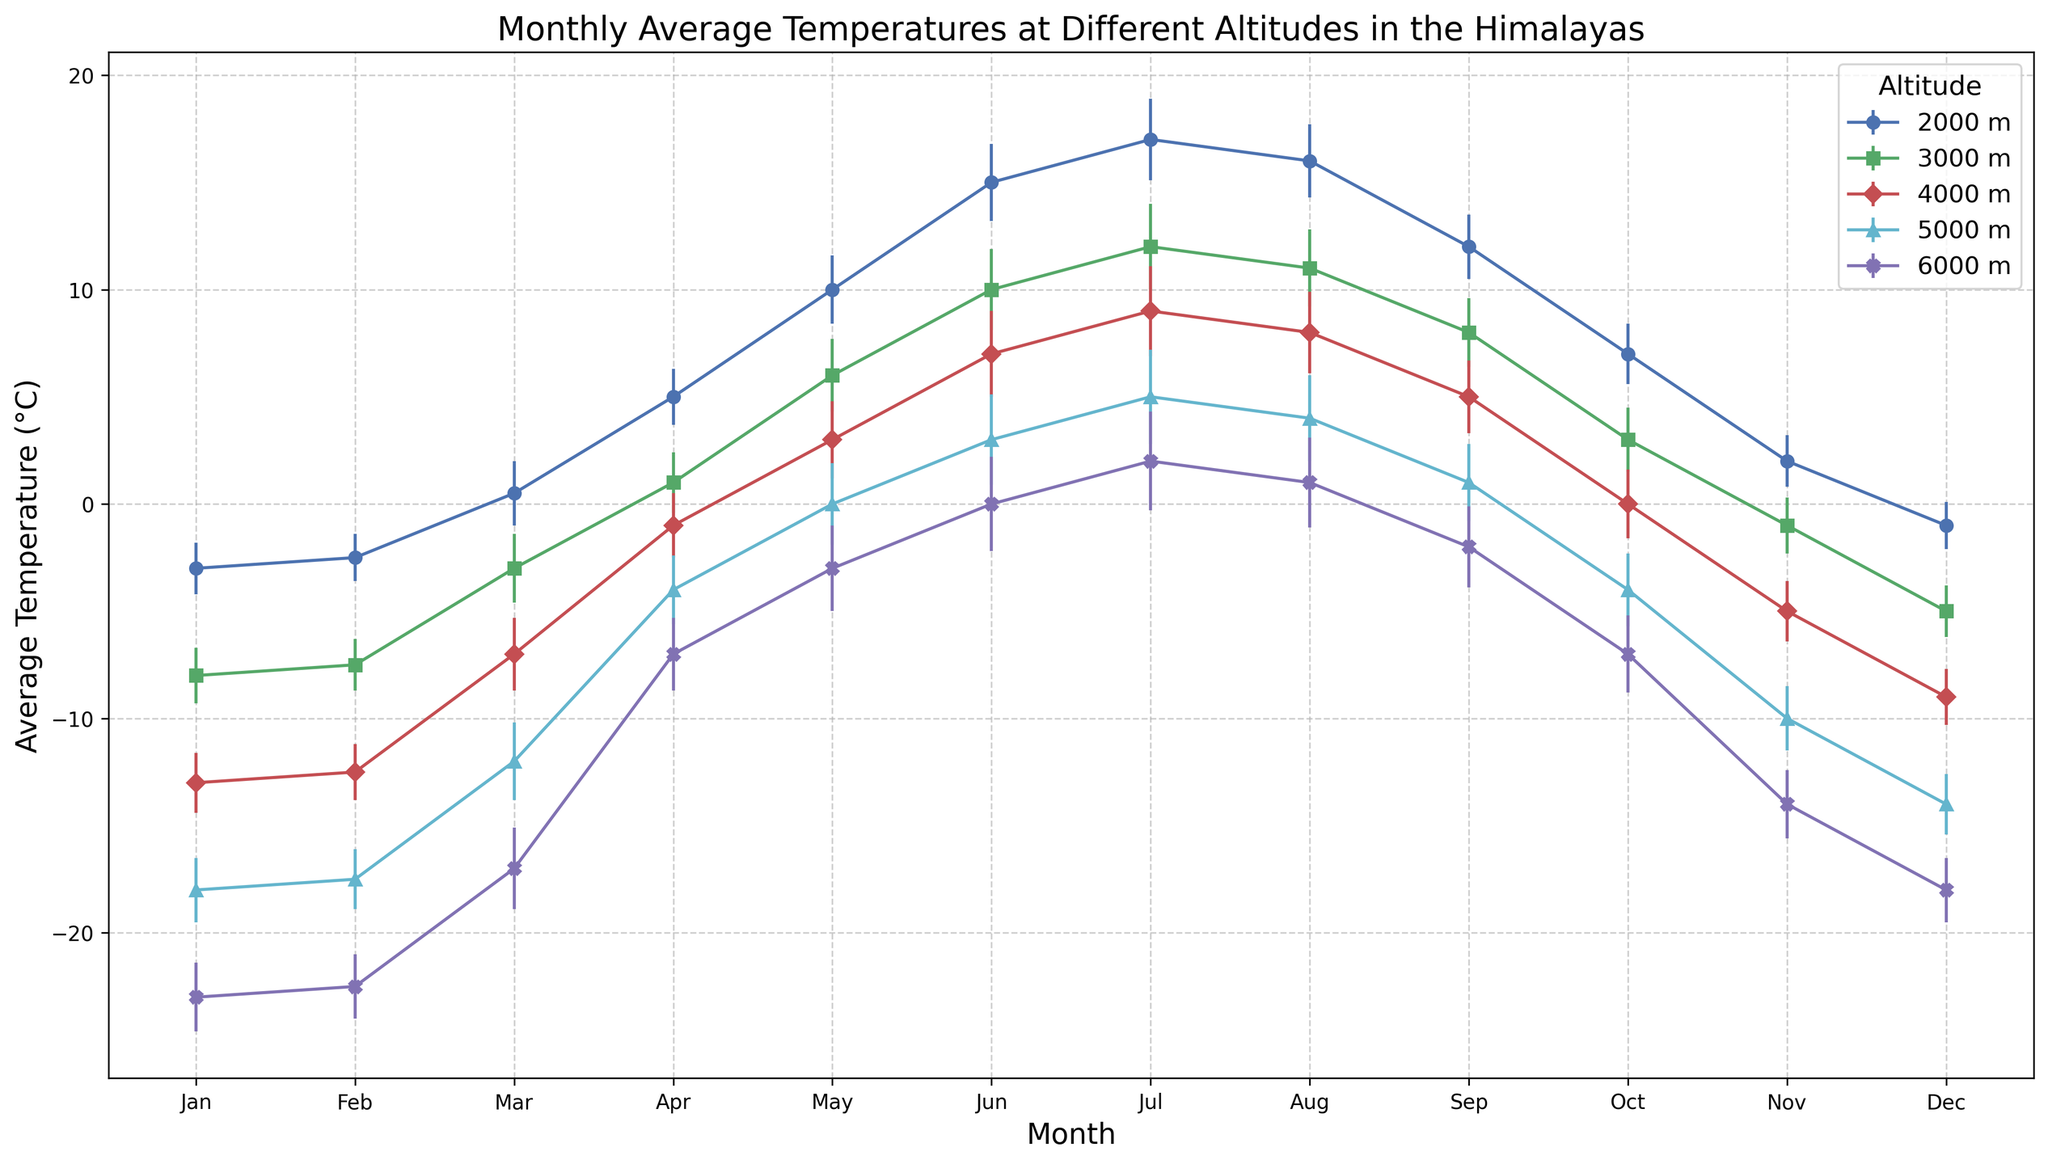What is the average temperature in July at 3000 m altitude? Look at the data points for July at the 3000 m altitude. The data point shows the temperature for July at this altitude.
Answer: 12°C Which month has the maximum average temperature at 5000 m altitude, and what is the temperature? Examine the data points at 5000 m altitude across all months and identify the month with the highest average temperature and note its temperature.
Answer: July, 5°C What is the difference in average temperature between June and December at 2000 m altitude? Compare the data points for June and December at 2000 m altitude and subtract December's average temperature from June's average temperature.
Answer: 16°C Is the standard deviation of the temperature in January the same at all altitudes? Check the standard deviation values for January across all altitudes and determine if they are equal.
Answer: No In which month does the temperature at 4000 m altitude reach 0°C? Find the month at 4000 m altitude where the average temperature equals 0°C.
Answer: October How does the average temperature in August at 6000 m compare to the average temperature in August at 2000 m? Look at the average temperatures for August at both 6000 m and 2000 m and compare them directly.
Answer: Lower at 6000 m During which month does the temperature fluctuation (standard deviation) peak at 5000 m altitude, and what is the value? Identify the month at 5000 m altitude with the highest temperature standard deviation and note the value.
Answer: July, 2.2°C Which month shows the greatest temperature increase from the previous month at 3000 m altitude? Compare the differences in average temperatures from month to month at 3000 m altitude and identify the month with the largest increase.
Answer: March 